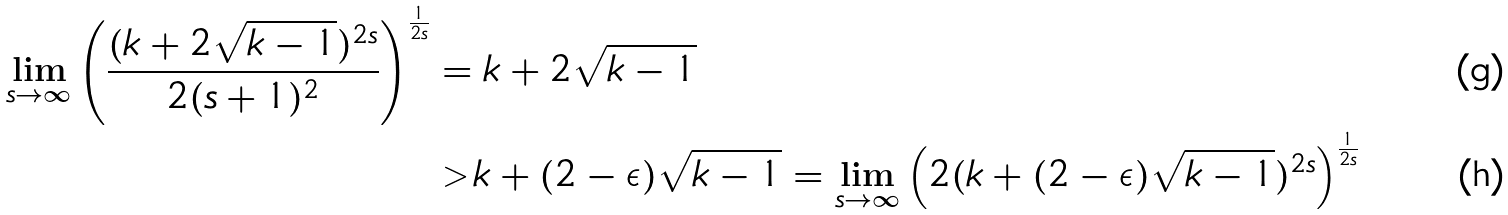Convert formula to latex. <formula><loc_0><loc_0><loc_500><loc_500>\lim _ { s \rightarrow \infty } \left ( \frac { ( k + 2 \sqrt { k - 1 } ) ^ { 2 s } } { 2 ( s + 1 ) ^ { 2 } } \right ) ^ { \frac { 1 } { 2 s } } & = k + 2 \sqrt { k - 1 } \\ & > k + ( 2 - \epsilon ) \sqrt { k - 1 } = \lim _ { s \rightarrow \infty } \left ( 2 ( k + ( 2 - \epsilon ) \sqrt { k - 1 } ) ^ { 2 s } \right ) ^ { \frac { 1 } { 2 s } }</formula> 